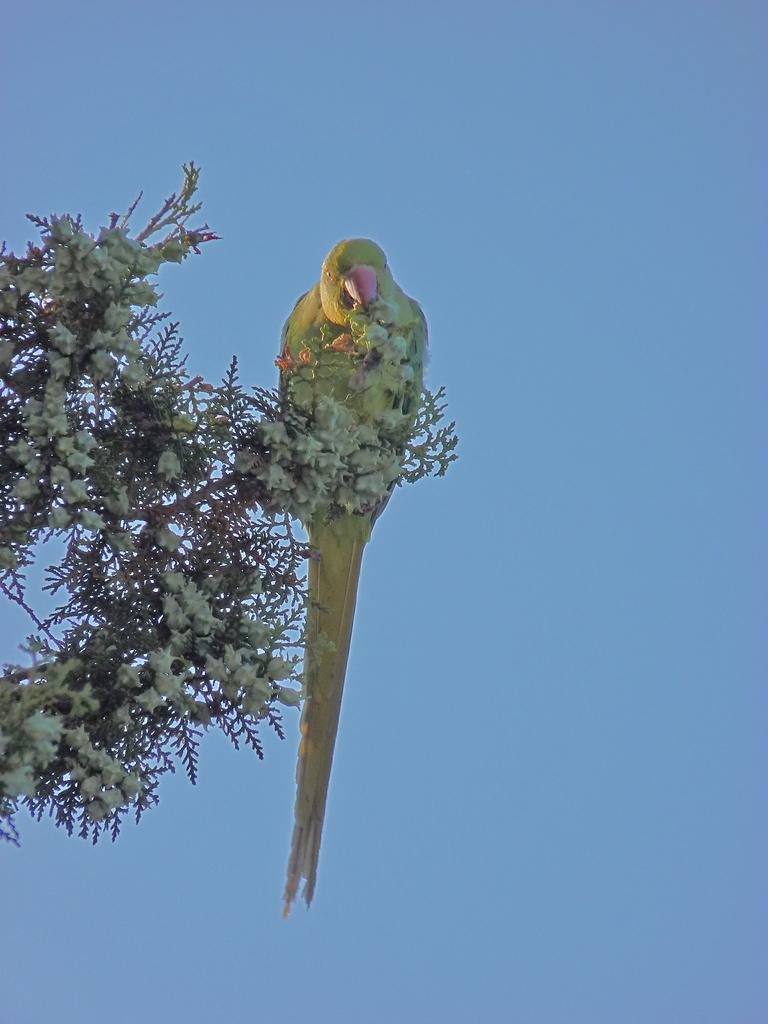What type of animal is in the image? There is a bird in the image. Where is the bird located in the image? The bird is on a plant. What is the plant in the image characterized by? The plant has flowers. What is visible in the background of the image? The background of the image includes the sky. What type of work is the bird doing in the image? The bird is not depicted as doing any work in the image; it is simply perched on a plant. What channel is the bird featured on in the image? The image is not a television channel, and therefore the bird is not featured on any channel in the image. 